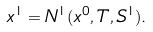<formula> <loc_0><loc_0><loc_500><loc_500>x ^ { 1 } = N ^ { 1 } ( x ^ { 0 } , T , S ^ { 1 } ) .</formula> 